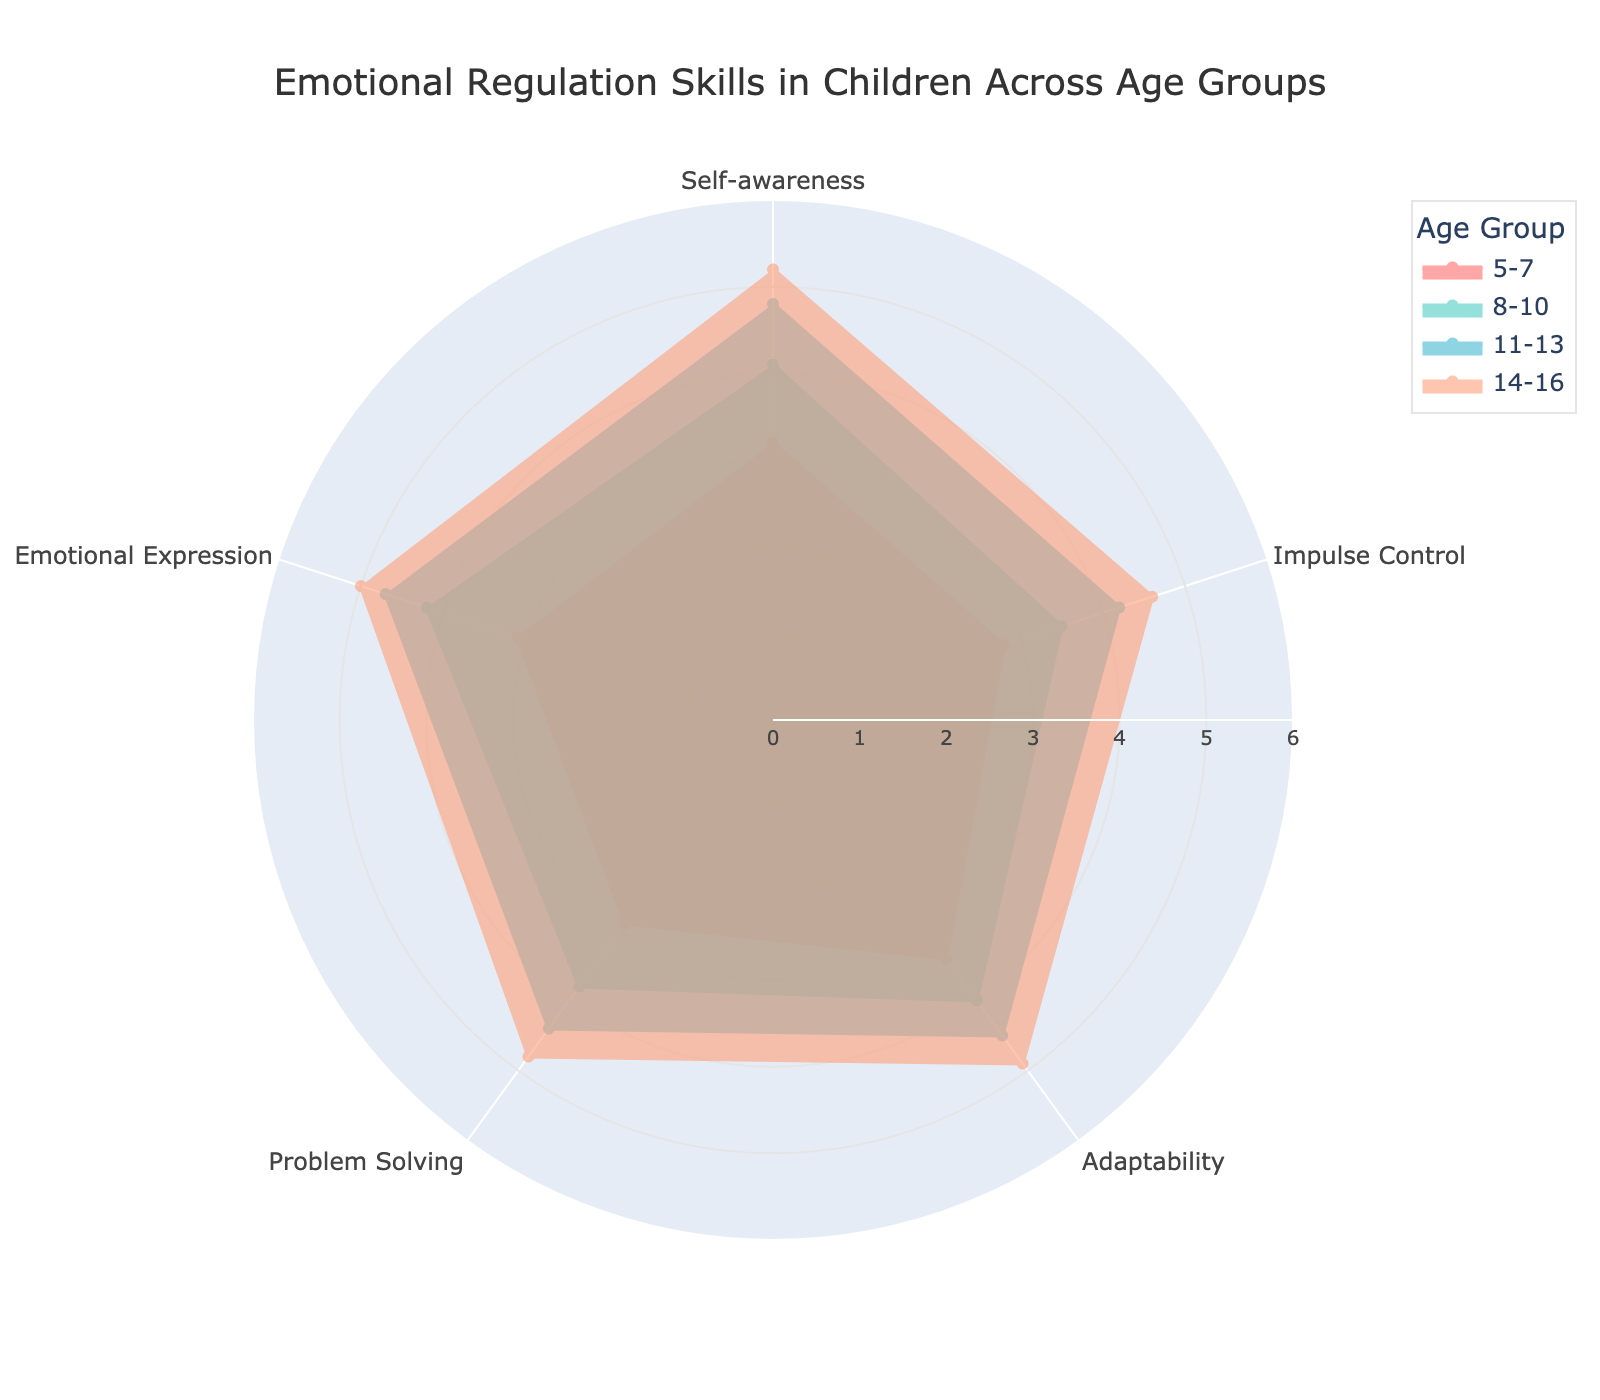What is the title of the radar chart? The title of the radar chart is located at the top center of the figure.
Answer: Emotional Regulation Skills in Children Across Age Groups Which age group has the highest value in Self-awareness? The Self-awareness values for each age group are visually represented by the points on the 'Self-awareness' axis. The group with the highest point on this axis indicates the highest value.
Answer: 14-16 In which category does the 11-13 age group show the lowest skill? By inspecting the radar chart, identify the point for the 11-13 age group's line that is closest to the center for the categories. This represents the lowest value.
Answer: Impulse Control What is the difference in Impulse Control skills between age groups 8-10 and 14-16? Compare the values on the 'Impulse Control' axis for the 8-10 and 14-16 age groups, then subtract the smaller value from the larger one.
Answer: 1.1 Which category shows the smallest improvement in performance from age group 5-7 to 8-10? Calculate the differences for each category between the 5-7 and 8-10 ages, then identify the category with the smallest difference.
Answer: Impulse Control In which category do all age groups show improvement as age increases? For each category, visually examine if the values increase consistently from the 5-7 age group to the 14-16 age group.
Answer: Emotional Expression Which age group demonstrates the most balanced emotional regulation skills across all categories? The most balanced skill set would show similar scores across all categories for that age group, forming a more uniform shape in their section of the radar chart.
Answer: 14-16 How does the Problem Solving skill compare between 11-13 and 14-16 age groups? Compare the points on the 'Problem Solving' axis for the 11-13 and 14-16 age groups. Determine if one is greater, lesser, or equal to the other.
Answer: 14-16 is higher What is the average Emotional Expression score of all age groups? Sum the Emotional Expression scores for all groups and then divide by the number of groups (4).
Answer: 4.25 Which category has the highest average value across all age groups? For each category, sum the values across all age groups and divide by the number of groups (4). Compare these averages to find the highest one.
Answer: Emotional Expression 